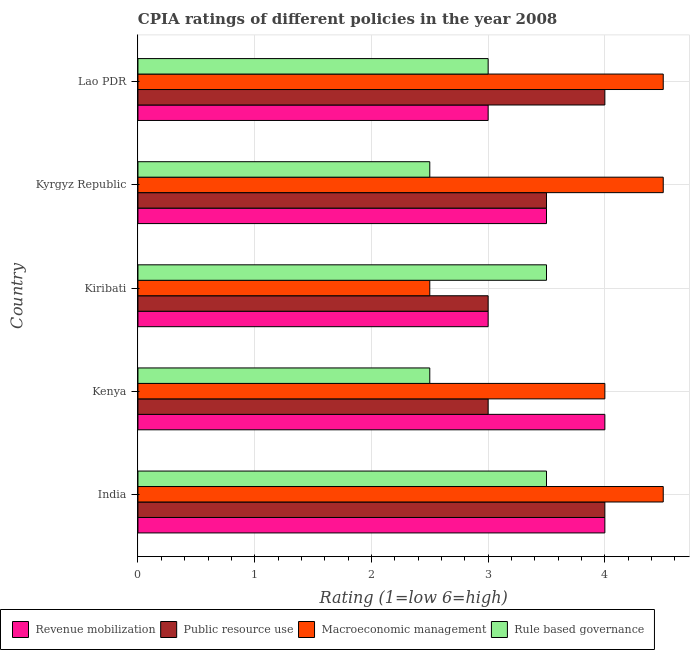Are the number of bars on each tick of the Y-axis equal?
Keep it short and to the point. Yes. How many bars are there on the 3rd tick from the top?
Provide a short and direct response. 4. How many bars are there on the 5th tick from the bottom?
Make the answer very short. 4. What is the label of the 4th group of bars from the top?
Offer a very short reply. Kenya. What is the cpia rating of public resource use in Kyrgyz Republic?
Make the answer very short. 3.5. Across all countries, what is the minimum cpia rating of public resource use?
Make the answer very short. 3. In which country was the cpia rating of public resource use maximum?
Offer a terse response. India. In which country was the cpia rating of rule based governance minimum?
Your response must be concise. Kenya. What is the total cpia rating of revenue mobilization in the graph?
Your answer should be compact. 17.5. What is the difference between the cpia rating of public resource use in Kenya and that in Kyrgyz Republic?
Offer a very short reply. -0.5. What is the difference between the cpia rating of rule based governance in Kyrgyz Republic and the cpia rating of macroeconomic management in Kiribati?
Ensure brevity in your answer.  0. What is the difference between the cpia rating of revenue mobilization and cpia rating of rule based governance in India?
Your answer should be very brief. 0.5. What is the ratio of the cpia rating of macroeconomic management in Kenya to that in Lao PDR?
Give a very brief answer. 0.89. Is the cpia rating of revenue mobilization in India less than that in Kiribati?
Your answer should be compact. No. What is the difference between the highest and the second highest cpia rating of macroeconomic management?
Offer a very short reply. 0. What is the difference between the highest and the lowest cpia rating of rule based governance?
Ensure brevity in your answer.  1. In how many countries, is the cpia rating of public resource use greater than the average cpia rating of public resource use taken over all countries?
Offer a terse response. 2. Is the sum of the cpia rating of macroeconomic management in Kenya and Kiribati greater than the maximum cpia rating of rule based governance across all countries?
Make the answer very short. Yes. What does the 1st bar from the top in Kenya represents?
Ensure brevity in your answer.  Rule based governance. What does the 2nd bar from the bottom in Kiribati represents?
Ensure brevity in your answer.  Public resource use. How many bars are there?
Your answer should be very brief. 20. Are all the bars in the graph horizontal?
Provide a succinct answer. Yes. How many countries are there in the graph?
Your answer should be compact. 5. Does the graph contain grids?
Provide a short and direct response. Yes. How many legend labels are there?
Make the answer very short. 4. How are the legend labels stacked?
Offer a terse response. Horizontal. What is the title of the graph?
Offer a very short reply. CPIA ratings of different policies in the year 2008. What is the label or title of the X-axis?
Keep it short and to the point. Rating (1=low 6=high). What is the label or title of the Y-axis?
Your answer should be compact. Country. What is the Rating (1=low 6=high) of Public resource use in India?
Provide a succinct answer. 4. What is the Rating (1=low 6=high) in Rule based governance in India?
Ensure brevity in your answer.  3.5. What is the Rating (1=low 6=high) of Revenue mobilization in Kenya?
Offer a terse response. 4. What is the Rating (1=low 6=high) in Public resource use in Kenya?
Ensure brevity in your answer.  3. What is the Rating (1=low 6=high) of Macroeconomic management in Kenya?
Provide a short and direct response. 4. What is the Rating (1=low 6=high) in Rule based governance in Kenya?
Ensure brevity in your answer.  2.5. What is the Rating (1=low 6=high) of Macroeconomic management in Kiribati?
Offer a terse response. 2.5. What is the Rating (1=low 6=high) in Rule based governance in Kiribati?
Offer a very short reply. 3.5. What is the Rating (1=low 6=high) of Public resource use in Kyrgyz Republic?
Offer a very short reply. 3.5. What is the Rating (1=low 6=high) of Public resource use in Lao PDR?
Give a very brief answer. 4. Across all countries, what is the maximum Rating (1=low 6=high) in Revenue mobilization?
Your answer should be very brief. 4. Across all countries, what is the maximum Rating (1=low 6=high) of Rule based governance?
Make the answer very short. 3.5. What is the total Rating (1=low 6=high) of Revenue mobilization in the graph?
Make the answer very short. 17.5. What is the total Rating (1=low 6=high) of Public resource use in the graph?
Give a very brief answer. 17.5. What is the total Rating (1=low 6=high) in Macroeconomic management in the graph?
Your answer should be compact. 20. What is the total Rating (1=low 6=high) of Rule based governance in the graph?
Provide a succinct answer. 15. What is the difference between the Rating (1=low 6=high) of Rule based governance in India and that in Kenya?
Offer a very short reply. 1. What is the difference between the Rating (1=low 6=high) of Revenue mobilization in India and that in Kiribati?
Ensure brevity in your answer.  1. What is the difference between the Rating (1=low 6=high) in Public resource use in India and that in Kiribati?
Provide a short and direct response. 1. What is the difference between the Rating (1=low 6=high) of Macroeconomic management in India and that in Kiribati?
Keep it short and to the point. 2. What is the difference between the Rating (1=low 6=high) in Revenue mobilization in India and that in Kyrgyz Republic?
Make the answer very short. 0.5. What is the difference between the Rating (1=low 6=high) of Public resource use in India and that in Kyrgyz Republic?
Keep it short and to the point. 0.5. What is the difference between the Rating (1=low 6=high) in Rule based governance in India and that in Kyrgyz Republic?
Make the answer very short. 1. What is the difference between the Rating (1=low 6=high) of Revenue mobilization in India and that in Lao PDR?
Offer a very short reply. 1. What is the difference between the Rating (1=low 6=high) in Public resource use in India and that in Lao PDR?
Offer a very short reply. 0. What is the difference between the Rating (1=low 6=high) of Macroeconomic management in India and that in Lao PDR?
Your answer should be compact. 0. What is the difference between the Rating (1=low 6=high) in Rule based governance in India and that in Lao PDR?
Offer a terse response. 0.5. What is the difference between the Rating (1=low 6=high) in Revenue mobilization in Kenya and that in Kiribati?
Keep it short and to the point. 1. What is the difference between the Rating (1=low 6=high) of Public resource use in Kenya and that in Kiribati?
Offer a very short reply. 0. What is the difference between the Rating (1=low 6=high) in Revenue mobilization in Kenya and that in Kyrgyz Republic?
Keep it short and to the point. 0.5. What is the difference between the Rating (1=low 6=high) in Public resource use in Kenya and that in Kyrgyz Republic?
Make the answer very short. -0.5. What is the difference between the Rating (1=low 6=high) in Rule based governance in Kenya and that in Lao PDR?
Your answer should be compact. -0.5. What is the difference between the Rating (1=low 6=high) of Revenue mobilization in Kiribati and that in Kyrgyz Republic?
Provide a short and direct response. -0.5. What is the difference between the Rating (1=low 6=high) of Public resource use in Kiribati and that in Kyrgyz Republic?
Your response must be concise. -0.5. What is the difference between the Rating (1=low 6=high) of Macroeconomic management in Kiribati and that in Kyrgyz Republic?
Your response must be concise. -2. What is the difference between the Rating (1=low 6=high) in Rule based governance in Kiribati and that in Kyrgyz Republic?
Give a very brief answer. 1. What is the difference between the Rating (1=low 6=high) of Public resource use in Kiribati and that in Lao PDR?
Your response must be concise. -1. What is the difference between the Rating (1=low 6=high) of Rule based governance in Kiribati and that in Lao PDR?
Ensure brevity in your answer.  0.5. What is the difference between the Rating (1=low 6=high) in Public resource use in Kyrgyz Republic and that in Lao PDR?
Your response must be concise. -0.5. What is the difference between the Rating (1=low 6=high) of Revenue mobilization in India and the Rating (1=low 6=high) of Public resource use in Kenya?
Your answer should be compact. 1. What is the difference between the Rating (1=low 6=high) in Revenue mobilization in India and the Rating (1=low 6=high) in Rule based governance in Kenya?
Make the answer very short. 1.5. What is the difference between the Rating (1=low 6=high) of Macroeconomic management in India and the Rating (1=low 6=high) of Rule based governance in Kenya?
Provide a short and direct response. 2. What is the difference between the Rating (1=low 6=high) in Revenue mobilization in India and the Rating (1=low 6=high) in Public resource use in Kiribati?
Your answer should be very brief. 1. What is the difference between the Rating (1=low 6=high) of Revenue mobilization in India and the Rating (1=low 6=high) of Macroeconomic management in Kiribati?
Ensure brevity in your answer.  1.5. What is the difference between the Rating (1=low 6=high) of Public resource use in India and the Rating (1=low 6=high) of Macroeconomic management in Kiribati?
Provide a succinct answer. 1.5. What is the difference between the Rating (1=low 6=high) in Public resource use in India and the Rating (1=low 6=high) in Rule based governance in Kiribati?
Make the answer very short. 0.5. What is the difference between the Rating (1=low 6=high) of Revenue mobilization in India and the Rating (1=low 6=high) of Macroeconomic management in Kyrgyz Republic?
Your response must be concise. -0.5. What is the difference between the Rating (1=low 6=high) in Public resource use in India and the Rating (1=low 6=high) in Macroeconomic management in Kyrgyz Republic?
Provide a short and direct response. -0.5. What is the difference between the Rating (1=low 6=high) in Public resource use in India and the Rating (1=low 6=high) in Rule based governance in Kyrgyz Republic?
Offer a very short reply. 1.5. What is the difference between the Rating (1=low 6=high) of Macroeconomic management in India and the Rating (1=low 6=high) of Rule based governance in Kyrgyz Republic?
Keep it short and to the point. 2. What is the difference between the Rating (1=low 6=high) in Revenue mobilization in India and the Rating (1=low 6=high) in Macroeconomic management in Lao PDR?
Keep it short and to the point. -0.5. What is the difference between the Rating (1=low 6=high) in Public resource use in India and the Rating (1=low 6=high) in Macroeconomic management in Lao PDR?
Ensure brevity in your answer.  -0.5. What is the difference between the Rating (1=low 6=high) of Revenue mobilization in Kenya and the Rating (1=low 6=high) of Rule based governance in Kiribati?
Provide a short and direct response. 0.5. What is the difference between the Rating (1=low 6=high) of Public resource use in Kenya and the Rating (1=low 6=high) of Macroeconomic management in Kiribati?
Give a very brief answer. 0.5. What is the difference between the Rating (1=low 6=high) in Public resource use in Kenya and the Rating (1=low 6=high) in Macroeconomic management in Kyrgyz Republic?
Your answer should be very brief. -1.5. What is the difference between the Rating (1=low 6=high) in Macroeconomic management in Kenya and the Rating (1=low 6=high) in Rule based governance in Kyrgyz Republic?
Offer a terse response. 1.5. What is the difference between the Rating (1=low 6=high) of Revenue mobilization in Kenya and the Rating (1=low 6=high) of Public resource use in Lao PDR?
Provide a short and direct response. 0. What is the difference between the Rating (1=low 6=high) in Public resource use in Kenya and the Rating (1=low 6=high) in Macroeconomic management in Lao PDR?
Make the answer very short. -1.5. What is the difference between the Rating (1=low 6=high) in Public resource use in Kenya and the Rating (1=low 6=high) in Rule based governance in Lao PDR?
Keep it short and to the point. 0. What is the difference between the Rating (1=low 6=high) of Macroeconomic management in Kenya and the Rating (1=low 6=high) of Rule based governance in Lao PDR?
Ensure brevity in your answer.  1. What is the difference between the Rating (1=low 6=high) of Macroeconomic management in Kiribati and the Rating (1=low 6=high) of Rule based governance in Kyrgyz Republic?
Provide a short and direct response. 0. What is the difference between the Rating (1=low 6=high) in Revenue mobilization in Kiribati and the Rating (1=low 6=high) in Macroeconomic management in Lao PDR?
Give a very brief answer. -1.5. What is the difference between the Rating (1=low 6=high) in Public resource use in Kiribati and the Rating (1=low 6=high) in Rule based governance in Lao PDR?
Your answer should be very brief. 0. What is the difference between the Rating (1=low 6=high) of Revenue mobilization in Kyrgyz Republic and the Rating (1=low 6=high) of Public resource use in Lao PDR?
Your answer should be compact. -0.5. What is the difference between the Rating (1=low 6=high) in Revenue mobilization in Kyrgyz Republic and the Rating (1=low 6=high) in Rule based governance in Lao PDR?
Provide a succinct answer. 0.5. What is the difference between the Rating (1=low 6=high) in Public resource use in Kyrgyz Republic and the Rating (1=low 6=high) in Macroeconomic management in Lao PDR?
Offer a terse response. -1. What is the difference between the Rating (1=low 6=high) in Public resource use in Kyrgyz Republic and the Rating (1=low 6=high) in Rule based governance in Lao PDR?
Your answer should be very brief. 0.5. What is the average Rating (1=low 6=high) of Rule based governance per country?
Make the answer very short. 3. What is the difference between the Rating (1=low 6=high) in Revenue mobilization and Rating (1=low 6=high) in Public resource use in India?
Your answer should be compact. 0. What is the difference between the Rating (1=low 6=high) in Revenue mobilization and Rating (1=low 6=high) in Macroeconomic management in India?
Provide a succinct answer. -0.5. What is the difference between the Rating (1=low 6=high) in Revenue mobilization and Rating (1=low 6=high) in Rule based governance in India?
Make the answer very short. 0.5. What is the difference between the Rating (1=low 6=high) of Macroeconomic management and Rating (1=low 6=high) of Rule based governance in India?
Provide a short and direct response. 1. What is the difference between the Rating (1=low 6=high) of Revenue mobilization and Rating (1=low 6=high) of Macroeconomic management in Kenya?
Make the answer very short. 0. What is the difference between the Rating (1=low 6=high) in Revenue mobilization and Rating (1=low 6=high) in Rule based governance in Kenya?
Give a very brief answer. 1.5. What is the difference between the Rating (1=low 6=high) in Public resource use and Rating (1=low 6=high) in Macroeconomic management in Kenya?
Keep it short and to the point. -1. What is the difference between the Rating (1=low 6=high) of Macroeconomic management and Rating (1=low 6=high) of Rule based governance in Kenya?
Ensure brevity in your answer.  1.5. What is the difference between the Rating (1=low 6=high) in Macroeconomic management and Rating (1=low 6=high) in Rule based governance in Kiribati?
Offer a very short reply. -1. What is the difference between the Rating (1=low 6=high) in Revenue mobilization and Rating (1=low 6=high) in Public resource use in Kyrgyz Republic?
Provide a short and direct response. 0. What is the difference between the Rating (1=low 6=high) of Public resource use and Rating (1=low 6=high) of Macroeconomic management in Kyrgyz Republic?
Make the answer very short. -1. What is the difference between the Rating (1=low 6=high) in Public resource use and Rating (1=low 6=high) in Rule based governance in Kyrgyz Republic?
Keep it short and to the point. 1. What is the difference between the Rating (1=low 6=high) of Macroeconomic management and Rating (1=low 6=high) of Rule based governance in Kyrgyz Republic?
Make the answer very short. 2. What is the difference between the Rating (1=low 6=high) of Revenue mobilization and Rating (1=low 6=high) of Public resource use in Lao PDR?
Make the answer very short. -1. What is the ratio of the Rating (1=low 6=high) in Revenue mobilization in India to that in Kenya?
Make the answer very short. 1. What is the ratio of the Rating (1=low 6=high) in Public resource use in India to that in Kiribati?
Make the answer very short. 1.33. What is the ratio of the Rating (1=low 6=high) in Rule based governance in India to that in Kiribati?
Your response must be concise. 1. What is the ratio of the Rating (1=low 6=high) in Public resource use in India to that in Kyrgyz Republic?
Offer a very short reply. 1.14. What is the ratio of the Rating (1=low 6=high) in Revenue mobilization in India to that in Lao PDR?
Your response must be concise. 1.33. What is the ratio of the Rating (1=low 6=high) in Macroeconomic management in India to that in Lao PDR?
Your answer should be compact. 1. What is the ratio of the Rating (1=low 6=high) in Macroeconomic management in Kenya to that in Kiribati?
Give a very brief answer. 1.6. What is the ratio of the Rating (1=low 6=high) of Rule based governance in Kenya to that in Kyrgyz Republic?
Offer a very short reply. 1. What is the ratio of the Rating (1=low 6=high) in Rule based governance in Kenya to that in Lao PDR?
Make the answer very short. 0.83. What is the ratio of the Rating (1=low 6=high) in Macroeconomic management in Kiribati to that in Kyrgyz Republic?
Your response must be concise. 0.56. What is the ratio of the Rating (1=low 6=high) of Public resource use in Kiribati to that in Lao PDR?
Your response must be concise. 0.75. What is the ratio of the Rating (1=low 6=high) of Macroeconomic management in Kiribati to that in Lao PDR?
Offer a terse response. 0.56. What is the ratio of the Rating (1=low 6=high) of Rule based governance in Kiribati to that in Lao PDR?
Ensure brevity in your answer.  1.17. What is the ratio of the Rating (1=low 6=high) of Revenue mobilization in Kyrgyz Republic to that in Lao PDR?
Provide a short and direct response. 1.17. What is the ratio of the Rating (1=low 6=high) in Public resource use in Kyrgyz Republic to that in Lao PDR?
Your answer should be very brief. 0.88. What is the ratio of the Rating (1=low 6=high) of Rule based governance in Kyrgyz Republic to that in Lao PDR?
Your answer should be compact. 0.83. What is the difference between the highest and the second highest Rating (1=low 6=high) of Revenue mobilization?
Provide a succinct answer. 0. What is the difference between the highest and the second highest Rating (1=low 6=high) of Public resource use?
Offer a terse response. 0. What is the difference between the highest and the second highest Rating (1=low 6=high) in Macroeconomic management?
Your answer should be compact. 0. What is the difference between the highest and the second highest Rating (1=low 6=high) in Rule based governance?
Provide a short and direct response. 0. What is the difference between the highest and the lowest Rating (1=low 6=high) of Public resource use?
Offer a very short reply. 1. 